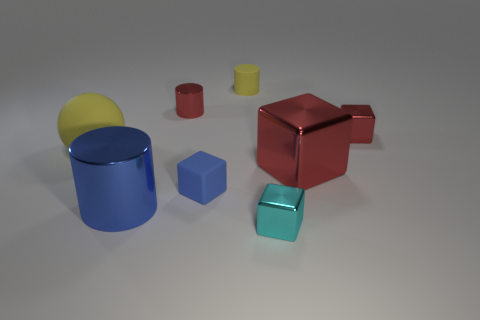Subtract all green cylinders. How many red blocks are left? 2 Subtract all tiny cubes. How many cubes are left? 1 Add 2 small purple shiny things. How many objects exist? 10 Subtract all red cylinders. How many cylinders are left? 2 Add 1 blue cubes. How many blue cubes exist? 2 Subtract 0 green spheres. How many objects are left? 8 Subtract all balls. How many objects are left? 7 Subtract all brown balls. Subtract all blue cylinders. How many balls are left? 1 Subtract all big yellow things. Subtract all red objects. How many objects are left? 4 Add 6 tiny blue blocks. How many tiny blue blocks are left? 7 